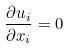<formula> <loc_0><loc_0><loc_500><loc_500>\frac { \partial u _ { i } } { \partial x _ { i } } = 0</formula> 